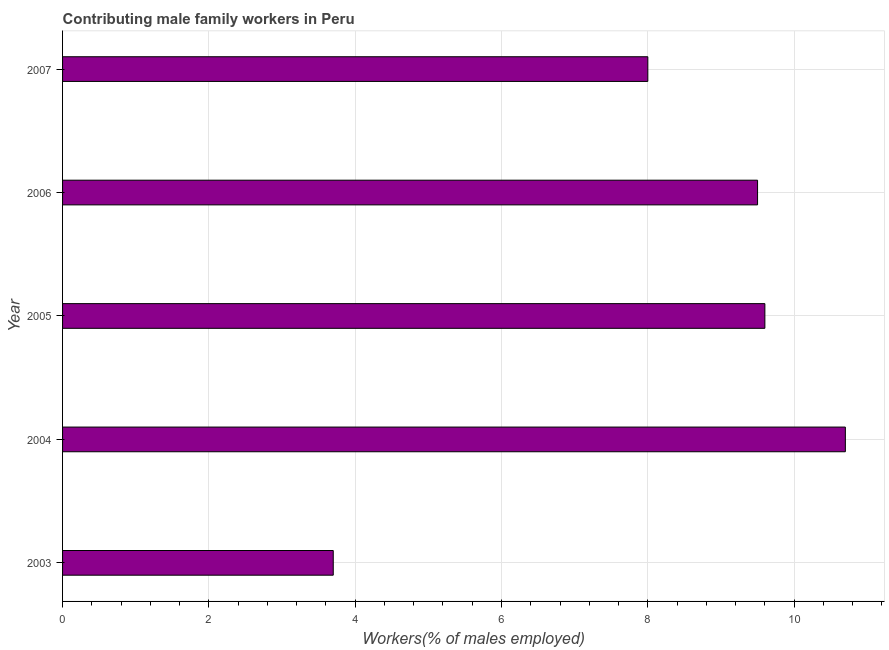What is the title of the graph?
Ensure brevity in your answer.  Contributing male family workers in Peru. What is the label or title of the X-axis?
Keep it short and to the point. Workers(% of males employed). Across all years, what is the maximum contributing male family workers?
Offer a terse response. 10.7. Across all years, what is the minimum contributing male family workers?
Keep it short and to the point. 3.7. What is the sum of the contributing male family workers?
Your answer should be very brief. 41.5. What is the difference between the contributing male family workers in 2003 and 2004?
Your answer should be very brief. -7. What is the average contributing male family workers per year?
Keep it short and to the point. 8.3. What is the median contributing male family workers?
Ensure brevity in your answer.  9.5. In how many years, is the contributing male family workers greater than 5.2 %?
Provide a succinct answer. 4. What is the ratio of the contributing male family workers in 2005 to that in 2007?
Your answer should be very brief. 1.2. What is the difference between the highest and the second highest contributing male family workers?
Your response must be concise. 1.1. In how many years, is the contributing male family workers greater than the average contributing male family workers taken over all years?
Your answer should be very brief. 3. Are the values on the major ticks of X-axis written in scientific E-notation?
Your answer should be compact. No. What is the Workers(% of males employed) of 2003?
Provide a short and direct response. 3.7. What is the Workers(% of males employed) of 2004?
Give a very brief answer. 10.7. What is the Workers(% of males employed) in 2005?
Offer a very short reply. 9.6. What is the Workers(% of males employed) of 2007?
Your answer should be compact. 8. What is the difference between the Workers(% of males employed) in 2003 and 2004?
Your answer should be very brief. -7. What is the difference between the Workers(% of males employed) in 2003 and 2005?
Offer a terse response. -5.9. What is the difference between the Workers(% of males employed) in 2003 and 2006?
Your answer should be very brief. -5.8. What is the difference between the Workers(% of males employed) in 2004 and 2005?
Offer a very short reply. 1.1. What is the difference between the Workers(% of males employed) in 2004 and 2006?
Your answer should be compact. 1.2. What is the difference between the Workers(% of males employed) in 2004 and 2007?
Offer a very short reply. 2.7. What is the difference between the Workers(% of males employed) in 2006 and 2007?
Provide a succinct answer. 1.5. What is the ratio of the Workers(% of males employed) in 2003 to that in 2004?
Keep it short and to the point. 0.35. What is the ratio of the Workers(% of males employed) in 2003 to that in 2005?
Your response must be concise. 0.39. What is the ratio of the Workers(% of males employed) in 2003 to that in 2006?
Offer a very short reply. 0.39. What is the ratio of the Workers(% of males employed) in 2003 to that in 2007?
Offer a very short reply. 0.46. What is the ratio of the Workers(% of males employed) in 2004 to that in 2005?
Offer a terse response. 1.11. What is the ratio of the Workers(% of males employed) in 2004 to that in 2006?
Your answer should be very brief. 1.13. What is the ratio of the Workers(% of males employed) in 2004 to that in 2007?
Give a very brief answer. 1.34. What is the ratio of the Workers(% of males employed) in 2005 to that in 2006?
Your response must be concise. 1.01. What is the ratio of the Workers(% of males employed) in 2005 to that in 2007?
Ensure brevity in your answer.  1.2. What is the ratio of the Workers(% of males employed) in 2006 to that in 2007?
Offer a very short reply. 1.19. 